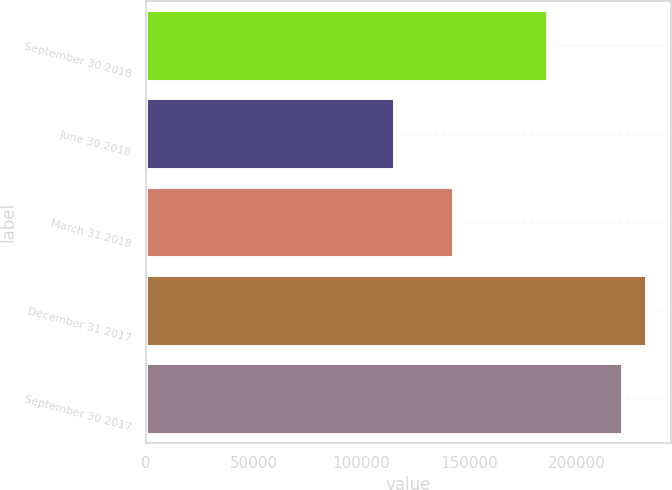Convert chart to OTSL. <chart><loc_0><loc_0><loc_500><loc_500><bar_chart><fcel>September 30 2018<fcel>June 30 2018<fcel>March 31 2018<fcel>December 31 2017<fcel>September 30 2017<nl><fcel>186205<fcel>115464<fcel>142791<fcel>232299<fcel>220942<nl></chart> 